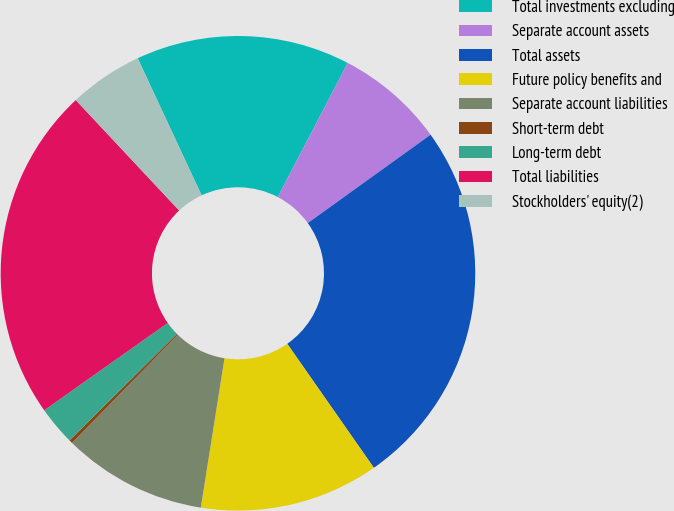<chart> <loc_0><loc_0><loc_500><loc_500><pie_chart><fcel>Total investments excluding<fcel>Separate account assets<fcel>Total assets<fcel>Future policy benefits and<fcel>Separate account liabilities<fcel>Short-term debt<fcel>Long-term debt<fcel>Total liabilities<fcel>Stockholders' equity(2)<nl><fcel>14.6%<fcel>7.42%<fcel>25.22%<fcel>12.21%<fcel>9.82%<fcel>0.24%<fcel>2.64%<fcel>22.82%<fcel>5.03%<nl></chart> 